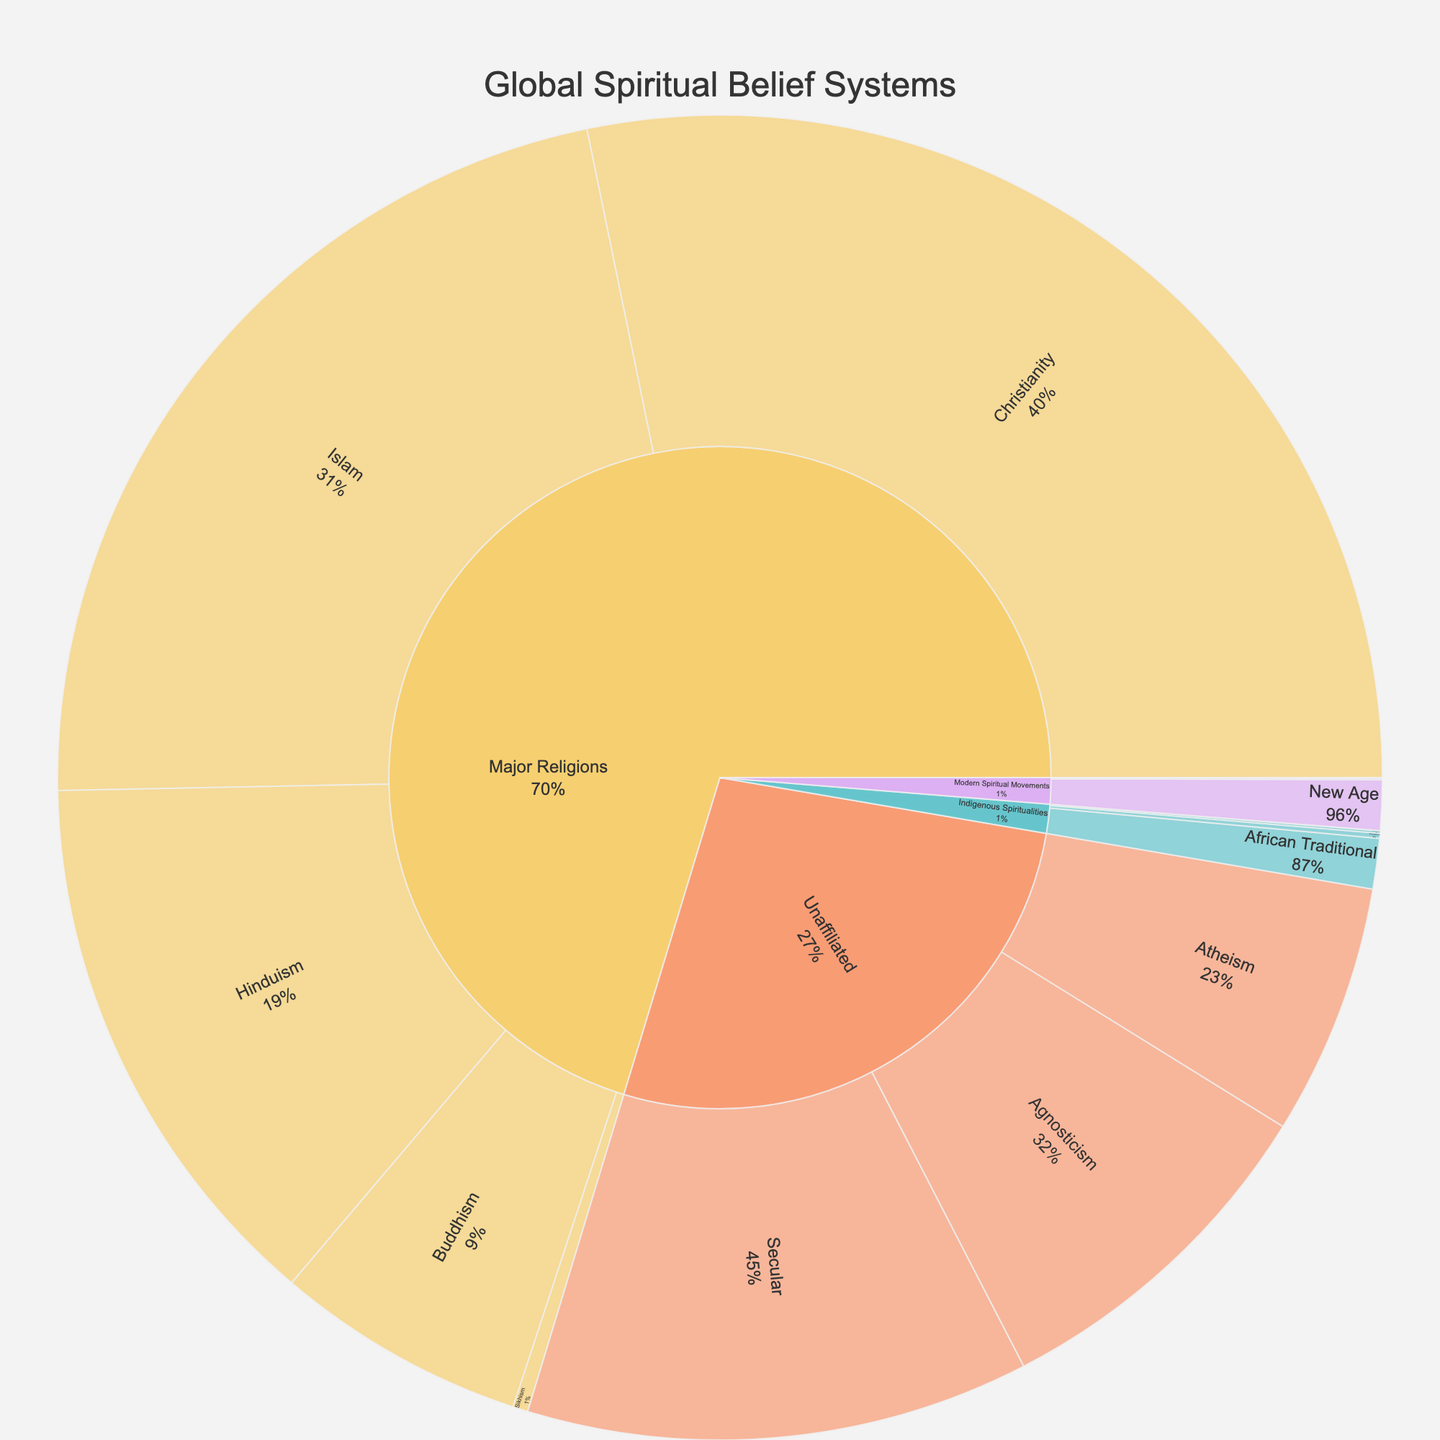what are the three largest individual spiritual belief systems by value? The three largest individual spiritual belief systems can be observed by looking at the subcategories with the highest values in the figure. The subcategories are shown inside the broader categories of Major Religions, Indigenous Spiritualities, Modern Spiritual Movements, and Unaffiliated. Comparing these values, we see that Christianity, Islam, and Secular are the three largest.
Answer: Christianity, Islam, Secular Which category has the smallest total value, and what is it? To find the category with the smallest total value, sum up the values of the subcategories under each main category. Indigenous Spiritualities have the smallest total by summing: Native American (5), African Traditional (100), Australian Aboriginal (0.3), and Shamanism (10), which equals 115.3. Other categories have higher sums.
Answer: Indigenous Spiritualities, 115.3 How does the number of adherents of Hinduism compare to the combined number of adherents of New Age and Atheism? Hinduism has 1100 adherents. To find the combined number of adherents of New Age and Atheism, sum up their values: New Age (100) + Atheism (500) = 600. By comparing these, it shows that Hinduism has more adherents than the combined number of New Age and Atheism.
Answer: Hinduism has more adherents What percentage of the total do Major Religions account for? The total value of all belief systems is the sum of the values of all subcategories. Sum the values: Major Religions (2300 + 1800 + 1100 + 500 + 30) + Indigenous Spiritualities (115.3) + Modern Spiritual Movements (100 + 3 + 1 + 0.1 + 0.05) + Unaffiliated (500 + 700 + 1000). This totals to 8149.45. Major Religions total is 5730. To get the percentage: (5730 / 8149.45) * 100% ≈ 70.3%.
Answer: Approximately 70.3% Which group within the Unaaffiliated category has the highest value? Look at the subcategories under Unaffiliated, comparing their values. The highest value among Atheism, Agnosticism, and Secular is Secular, with 1000 adherents.
Answer: Secular If one spiritual belief movement is randomly selected from Modern Spiritual Movements, what is the probability it will be New Age? The total value of Modern Spiritual Movements is the sum of New Age (100), Wicca (3), Neopaganism (1), Theosophy (0.1), and Scientology (0.05), which equals 104.15. The probability is New Age's value divided by the total of Modern Spiritual Movements: 100 / 104.15 ≈ 0.96 or 96%.
Answer: 96% How many more adherents does the largest subcategory have compared to the smallest subcategory? The largest subcategory is Christianity with 2300 adherents. The smallest is Scientology with 0.05 adherents. The difference is 2300 - 0.05 = 2299.95.
Answer: 2299.95 Are there more adherents of Buddhism or Agnosticism? Check the values for Buddhism (500) and Agnosticism (700). Agnosticism has more adherents than Buddhism by comparing these values.
Answer: Agnosticism What are the values for the Indigenous Spiritualities subcategories when summed up? Sum the values of all subcategories under Indigenous Spiritualities: Native American (5) + African Traditional (100) + Australian Aboriginal (0.3) + Shamanism (10). The sum is 115.3.
Answer: 115.3 